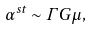<formula> <loc_0><loc_0><loc_500><loc_500>\alpha ^ { s t } \sim \Gamma G \mu ,</formula> 